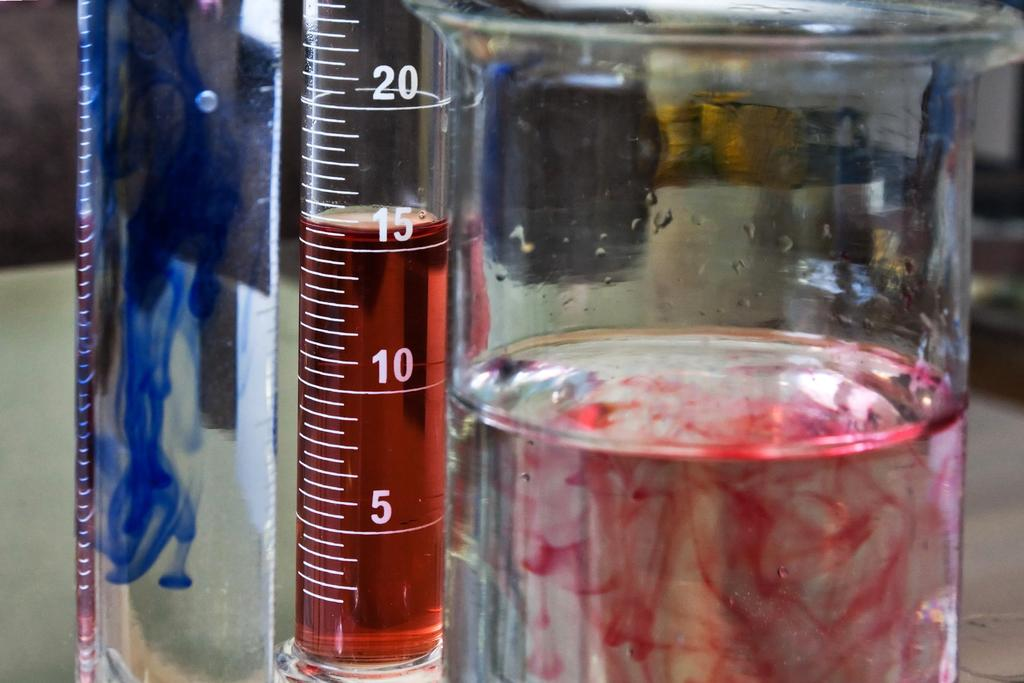<image>
Relay a brief, clear account of the picture shown. A graduated cylinder is filled with red liquid up to the 15 milliliter mark. 